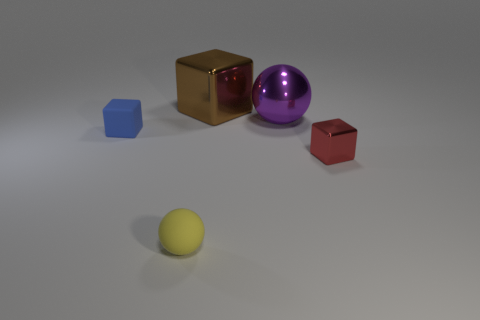Subtract all metallic cubes. How many cubes are left? 1 Add 3 big green matte spheres. How many objects exist? 8 Subtract all balls. How many objects are left? 3 Add 3 purple metal objects. How many purple metal objects exist? 4 Subtract 0 gray spheres. How many objects are left? 5 Subtract all small brown spheres. Subtract all big blocks. How many objects are left? 4 Add 4 small red objects. How many small red objects are left? 5 